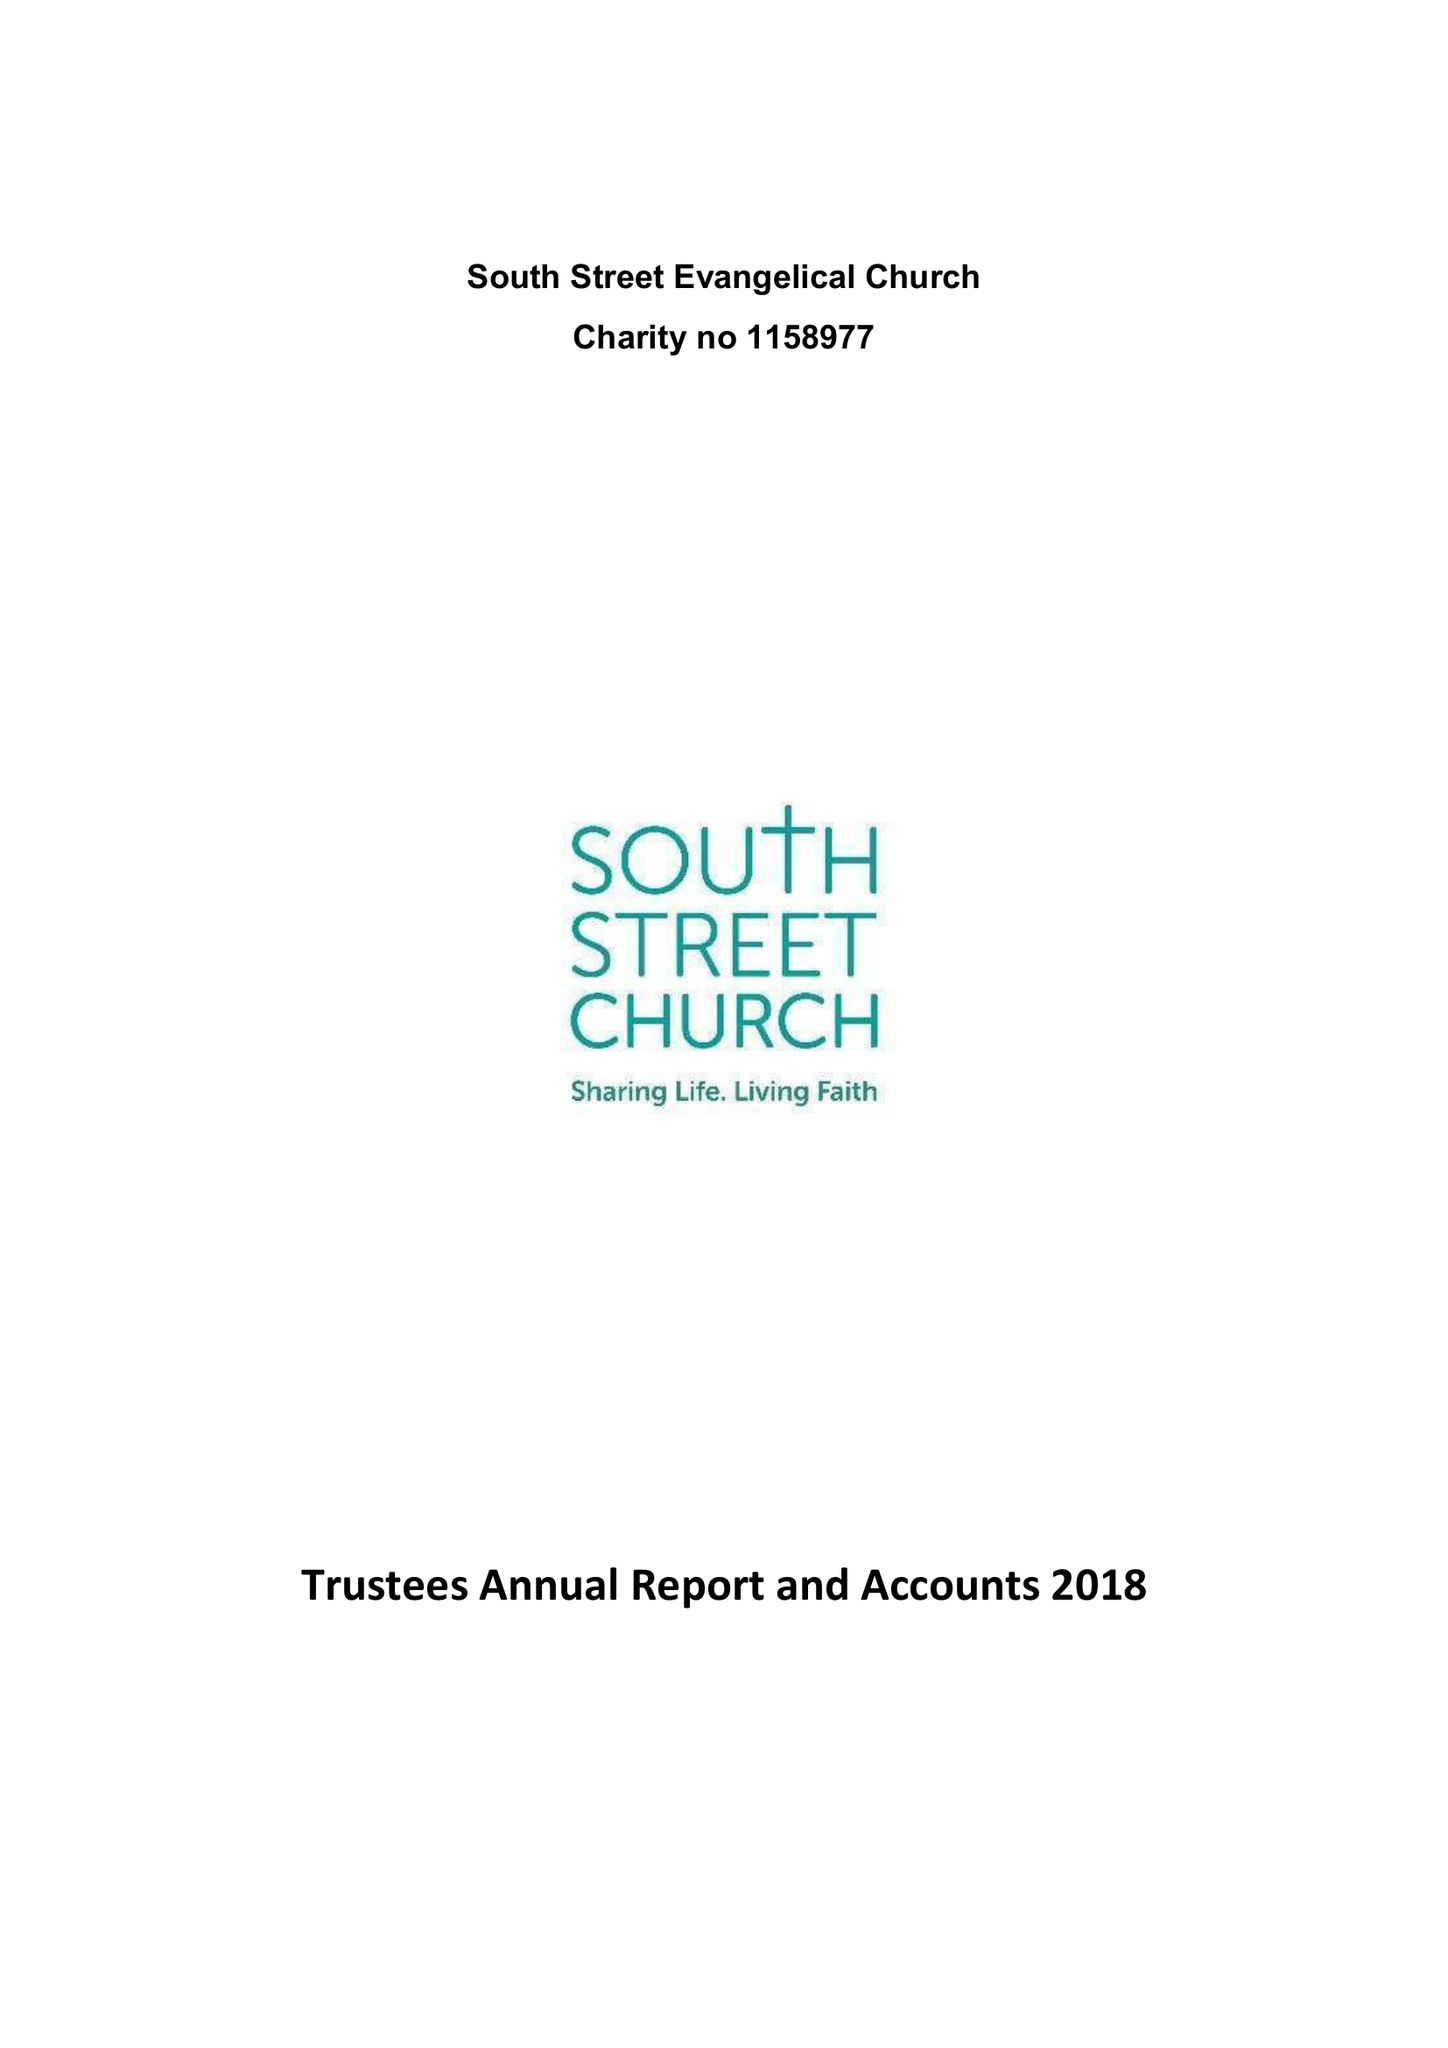What is the value for the report_date?
Answer the question using a single word or phrase. 2018-12-31 